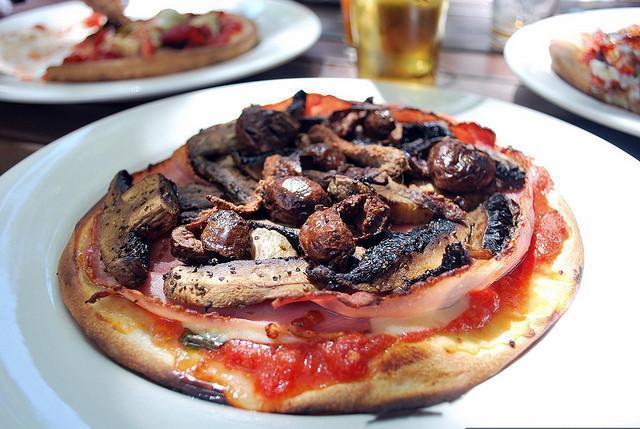How many pizzas are in the photo?
Give a very brief answer. 3. How many skateboards are visible?
Give a very brief answer. 0. 